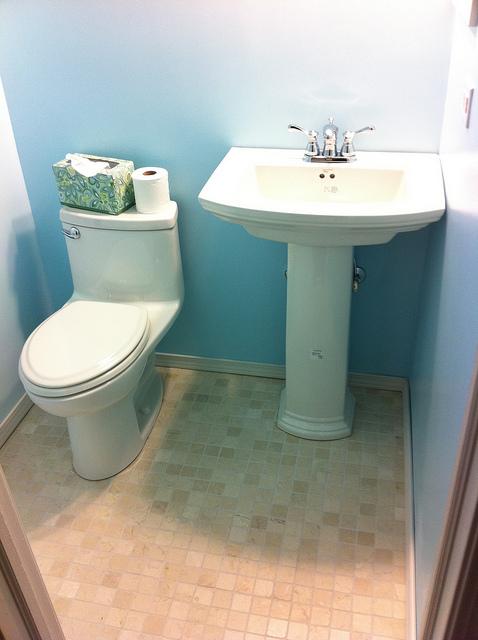Is this a half bath or a full bath?
Keep it brief. Half. Are the floor tiles even?
Concise answer only. Yes. What color is the tissue box?
Answer briefly. Green. 